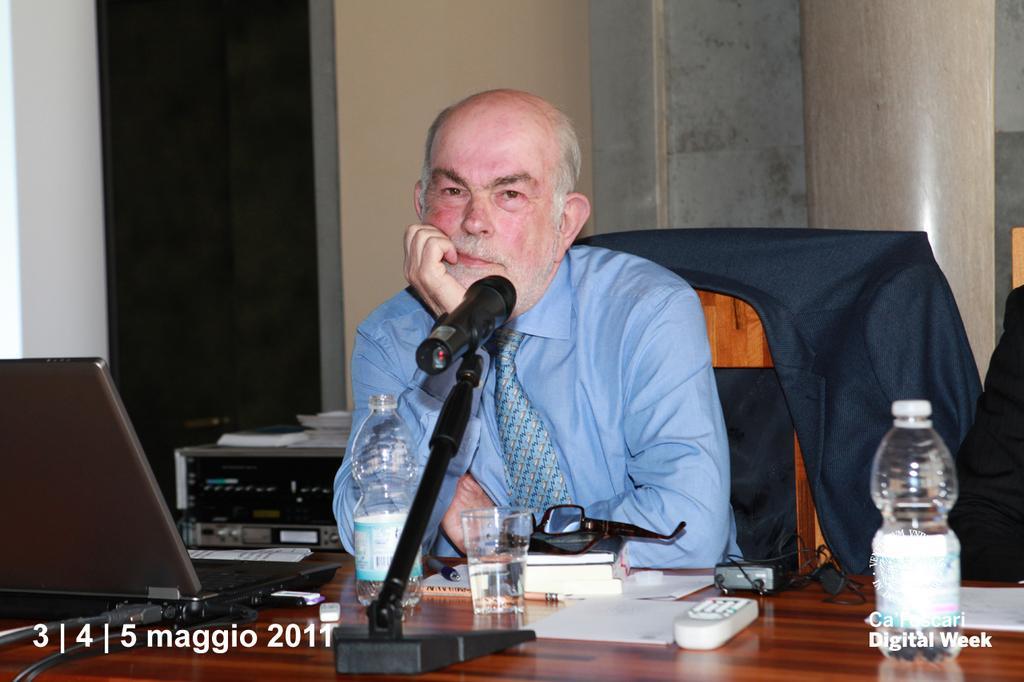In one or two sentences, can you explain what this image depicts? This image consists of a man wearing a blue shirt and a tie. He is sitting in a chair. And we can see a suit on the chair. In the front, we can see a table on which there are books, bottles, laptop. mic and a glass. In the background, there is a wall. 